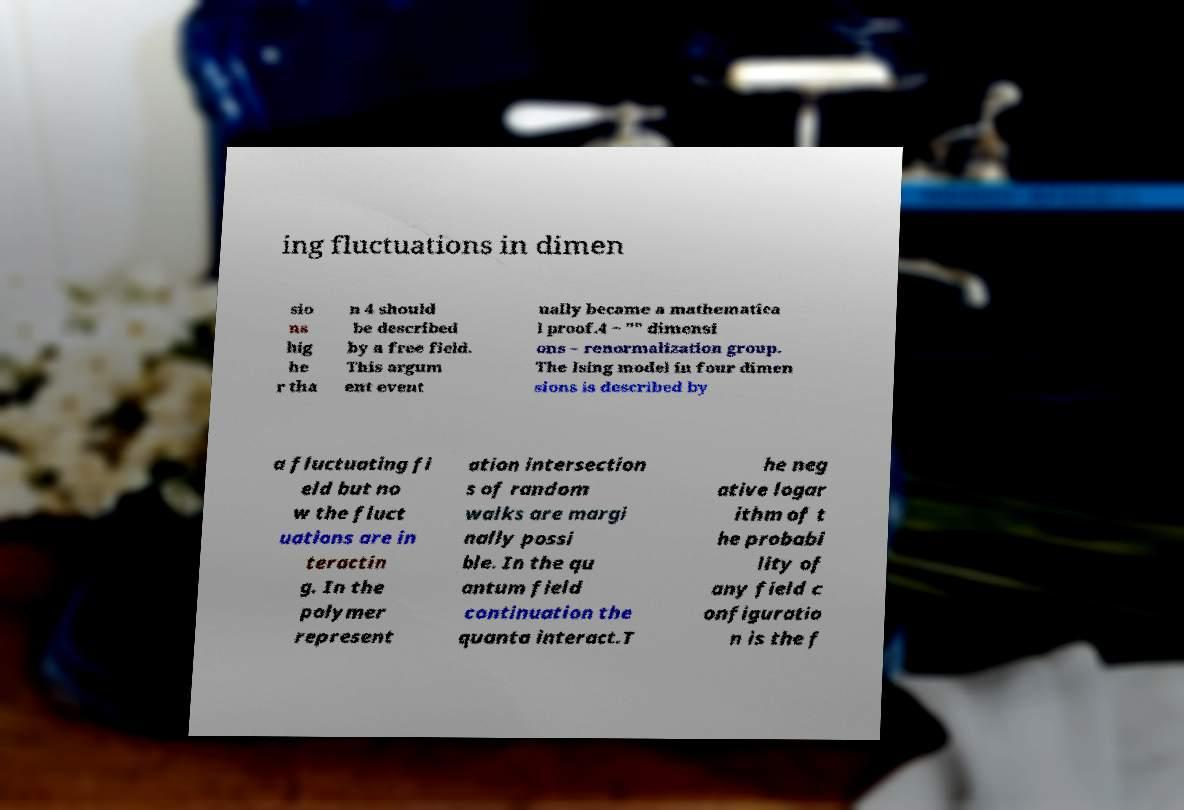I need the written content from this picture converted into text. Can you do that? ing fluctuations in dimen sio ns hig he r tha n 4 should be described by a free field. This argum ent event ually became a mathematica l proof.4 − "" dimensi ons – renormalization group. The Ising model in four dimen sions is described by a fluctuating fi eld but no w the fluct uations are in teractin g. In the polymer represent ation intersection s of random walks are margi nally possi ble. In the qu antum field continuation the quanta interact.T he neg ative logar ithm of t he probabi lity of any field c onfiguratio n is the f 